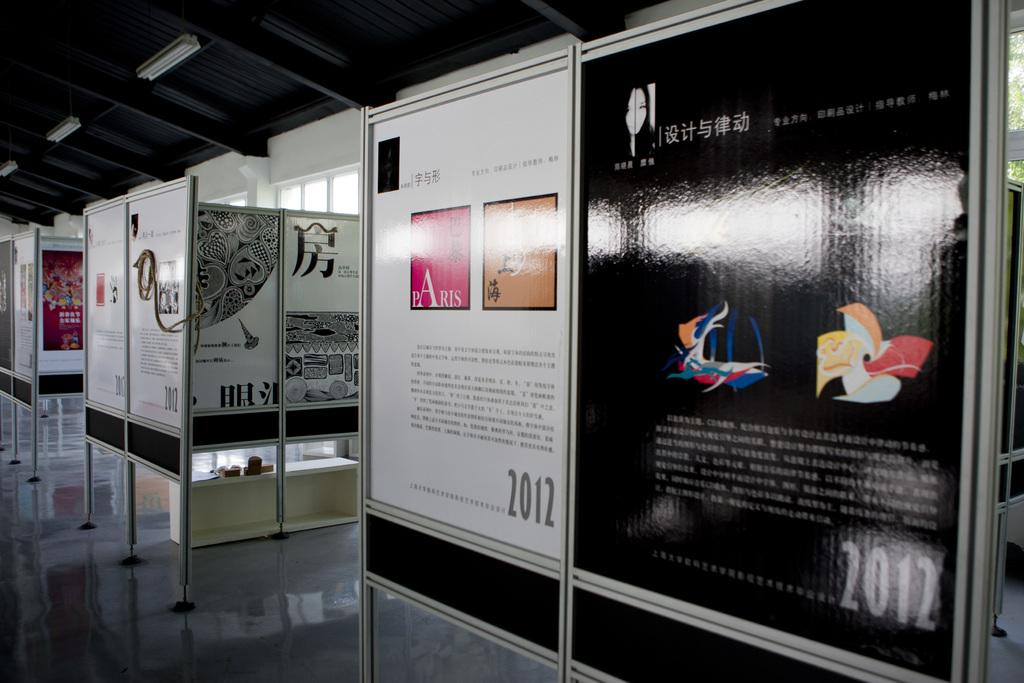What objects can be seen in the image? There are boards and lights in the image. What is written on the boards? There is writing on the boards. Is there a volcano erupting in the image? No, there is no volcano present in the image. What type of jewel can be seen hanging from the lights in the image? There are no jewels present in the image; it features boards with writing and lights. 